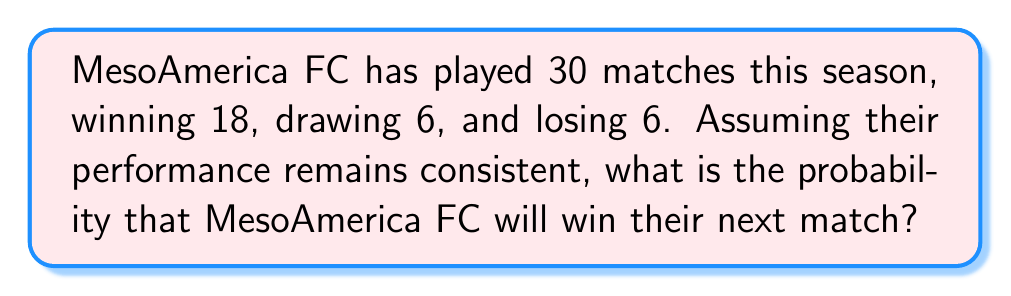Can you answer this question? To solve this problem, we need to use the concept of probability based on past events. Here's a step-by-step explanation:

1. First, let's identify the total number of matches and the number of wins:
   - Total matches: 30
   - Wins: 18

2. The probability of an event is calculated by dividing the number of favorable outcomes by the total number of possible outcomes. In this case:

   $$P(\text{win}) = \frac{\text{Number of wins}}{\text{Total number of matches}}$$

3. Substituting the values:

   $$P(\text{win}) = \frac{18}{30}$$

4. Simplify the fraction:

   $$P(\text{win}) = \frac{3}{5} = 0.6$$

5. To express this as a percentage, multiply by 100:

   $$P(\text{win}) = 0.6 \times 100\% = 60\%$$

Therefore, based on MesoAmerica FC's past performance this season, there is a 60% probability that they will win their next match.
Answer: $\frac{3}{5}$ or $0.6$ or $60\%$ 